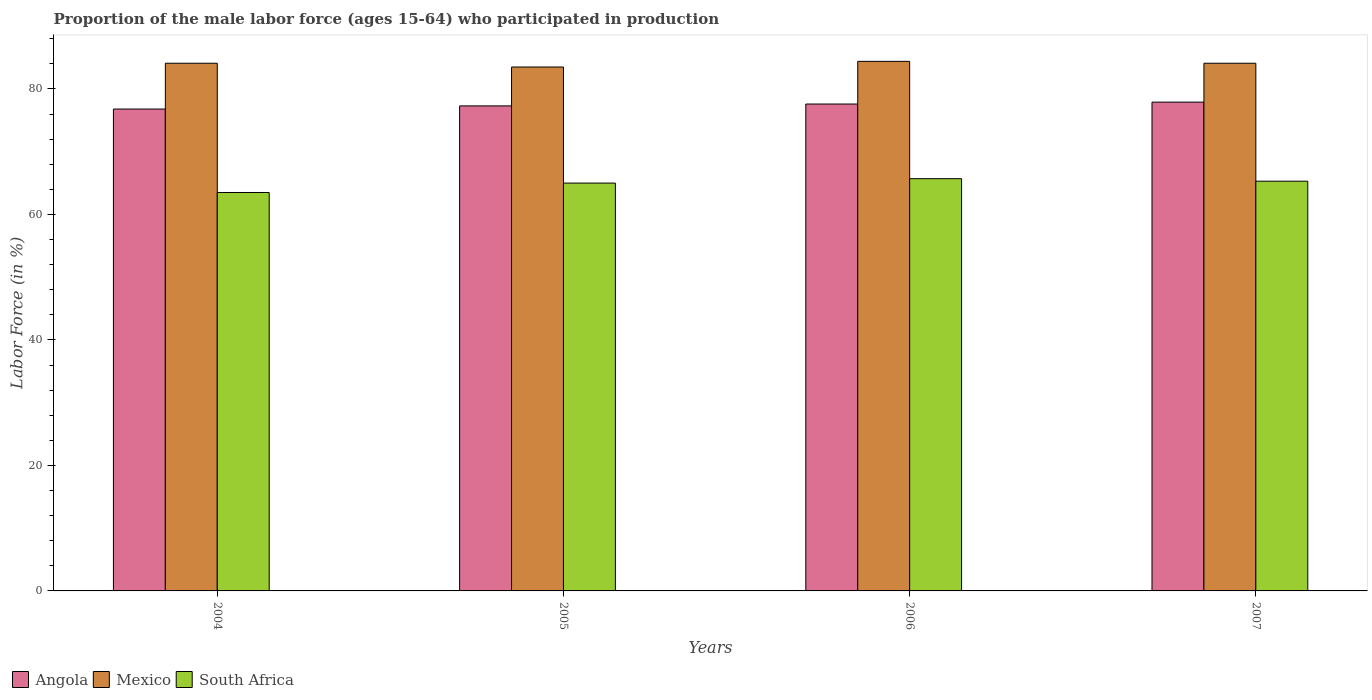How many different coloured bars are there?
Your response must be concise. 3. How many groups of bars are there?
Give a very brief answer. 4. Are the number of bars per tick equal to the number of legend labels?
Provide a short and direct response. Yes. Are the number of bars on each tick of the X-axis equal?
Ensure brevity in your answer.  Yes. How many bars are there on the 3rd tick from the left?
Provide a succinct answer. 3. What is the label of the 4th group of bars from the left?
Your answer should be compact. 2007. Across all years, what is the maximum proportion of the male labor force who participated in production in Angola?
Your answer should be very brief. 77.9. Across all years, what is the minimum proportion of the male labor force who participated in production in Angola?
Give a very brief answer. 76.8. In which year was the proportion of the male labor force who participated in production in South Africa minimum?
Ensure brevity in your answer.  2004. What is the total proportion of the male labor force who participated in production in South Africa in the graph?
Provide a short and direct response. 259.5. What is the difference between the proportion of the male labor force who participated in production in South Africa in 2004 and that in 2007?
Provide a short and direct response. -1.8. What is the difference between the proportion of the male labor force who participated in production in South Africa in 2007 and the proportion of the male labor force who participated in production in Angola in 2005?
Ensure brevity in your answer.  -12. What is the average proportion of the male labor force who participated in production in Angola per year?
Provide a succinct answer. 77.4. In the year 2005, what is the difference between the proportion of the male labor force who participated in production in Mexico and proportion of the male labor force who participated in production in South Africa?
Your answer should be very brief. 18.5. In how many years, is the proportion of the male labor force who participated in production in South Africa greater than 44 %?
Make the answer very short. 4. What is the ratio of the proportion of the male labor force who participated in production in Angola in 2004 to that in 2005?
Provide a short and direct response. 0.99. Is the proportion of the male labor force who participated in production in South Africa in 2006 less than that in 2007?
Provide a short and direct response. No. What is the difference between the highest and the second highest proportion of the male labor force who participated in production in Mexico?
Offer a very short reply. 0.3. What is the difference between the highest and the lowest proportion of the male labor force who participated in production in Mexico?
Keep it short and to the point. 0.9. In how many years, is the proportion of the male labor force who participated in production in Angola greater than the average proportion of the male labor force who participated in production in Angola taken over all years?
Offer a very short reply. 2. Is the sum of the proportion of the male labor force who participated in production in Angola in 2004 and 2007 greater than the maximum proportion of the male labor force who participated in production in South Africa across all years?
Offer a very short reply. Yes. What does the 2nd bar from the left in 2006 represents?
Give a very brief answer. Mexico. What does the 2nd bar from the right in 2005 represents?
Offer a very short reply. Mexico. Are all the bars in the graph horizontal?
Ensure brevity in your answer.  No. How many years are there in the graph?
Your answer should be very brief. 4. Are the values on the major ticks of Y-axis written in scientific E-notation?
Your response must be concise. No. How many legend labels are there?
Give a very brief answer. 3. What is the title of the graph?
Keep it short and to the point. Proportion of the male labor force (ages 15-64) who participated in production. What is the label or title of the Y-axis?
Your response must be concise. Labor Force (in %). What is the Labor Force (in %) of Angola in 2004?
Give a very brief answer. 76.8. What is the Labor Force (in %) in Mexico in 2004?
Your answer should be compact. 84.1. What is the Labor Force (in %) in South Africa in 2004?
Provide a short and direct response. 63.5. What is the Labor Force (in %) of Angola in 2005?
Make the answer very short. 77.3. What is the Labor Force (in %) of Mexico in 2005?
Your response must be concise. 83.5. What is the Labor Force (in %) of South Africa in 2005?
Ensure brevity in your answer.  65. What is the Labor Force (in %) of Angola in 2006?
Provide a short and direct response. 77.6. What is the Labor Force (in %) in Mexico in 2006?
Your response must be concise. 84.4. What is the Labor Force (in %) of South Africa in 2006?
Your answer should be very brief. 65.7. What is the Labor Force (in %) of Angola in 2007?
Give a very brief answer. 77.9. What is the Labor Force (in %) in Mexico in 2007?
Offer a very short reply. 84.1. What is the Labor Force (in %) of South Africa in 2007?
Give a very brief answer. 65.3. Across all years, what is the maximum Labor Force (in %) of Angola?
Your response must be concise. 77.9. Across all years, what is the maximum Labor Force (in %) in Mexico?
Ensure brevity in your answer.  84.4. Across all years, what is the maximum Labor Force (in %) of South Africa?
Your answer should be compact. 65.7. Across all years, what is the minimum Labor Force (in %) of Angola?
Give a very brief answer. 76.8. Across all years, what is the minimum Labor Force (in %) of Mexico?
Offer a terse response. 83.5. Across all years, what is the minimum Labor Force (in %) of South Africa?
Provide a succinct answer. 63.5. What is the total Labor Force (in %) of Angola in the graph?
Offer a very short reply. 309.6. What is the total Labor Force (in %) of Mexico in the graph?
Provide a short and direct response. 336.1. What is the total Labor Force (in %) of South Africa in the graph?
Make the answer very short. 259.5. What is the difference between the Labor Force (in %) in Mexico in 2004 and that in 2005?
Offer a very short reply. 0.6. What is the difference between the Labor Force (in %) in Mexico in 2004 and that in 2006?
Make the answer very short. -0.3. What is the difference between the Labor Force (in %) in Mexico in 2004 and that in 2007?
Ensure brevity in your answer.  0. What is the difference between the Labor Force (in %) in Angola in 2005 and that in 2006?
Provide a short and direct response. -0.3. What is the difference between the Labor Force (in %) of South Africa in 2005 and that in 2006?
Your answer should be compact. -0.7. What is the difference between the Labor Force (in %) of Mexico in 2006 and that in 2007?
Provide a succinct answer. 0.3. What is the difference between the Labor Force (in %) of Angola in 2004 and the Labor Force (in %) of South Africa in 2005?
Offer a very short reply. 11.8. What is the difference between the Labor Force (in %) of Mexico in 2004 and the Labor Force (in %) of South Africa in 2005?
Your answer should be very brief. 19.1. What is the difference between the Labor Force (in %) in Angola in 2004 and the Labor Force (in %) in South Africa in 2006?
Make the answer very short. 11.1. What is the difference between the Labor Force (in %) of Mexico in 2004 and the Labor Force (in %) of South Africa in 2007?
Provide a short and direct response. 18.8. What is the difference between the Labor Force (in %) in Angola in 2005 and the Labor Force (in %) in Mexico in 2006?
Keep it short and to the point. -7.1. What is the difference between the Labor Force (in %) of Mexico in 2005 and the Labor Force (in %) of South Africa in 2006?
Provide a short and direct response. 17.8. What is the difference between the Labor Force (in %) in Mexico in 2005 and the Labor Force (in %) in South Africa in 2007?
Offer a very short reply. 18.2. What is the difference between the Labor Force (in %) of Angola in 2006 and the Labor Force (in %) of Mexico in 2007?
Offer a terse response. -6.5. What is the difference between the Labor Force (in %) of Angola in 2006 and the Labor Force (in %) of South Africa in 2007?
Ensure brevity in your answer.  12.3. What is the difference between the Labor Force (in %) of Mexico in 2006 and the Labor Force (in %) of South Africa in 2007?
Your answer should be compact. 19.1. What is the average Labor Force (in %) in Angola per year?
Your response must be concise. 77.4. What is the average Labor Force (in %) of Mexico per year?
Keep it short and to the point. 84.03. What is the average Labor Force (in %) in South Africa per year?
Provide a short and direct response. 64.88. In the year 2004, what is the difference between the Labor Force (in %) in Angola and Labor Force (in %) in Mexico?
Provide a succinct answer. -7.3. In the year 2004, what is the difference between the Labor Force (in %) of Angola and Labor Force (in %) of South Africa?
Offer a very short reply. 13.3. In the year 2004, what is the difference between the Labor Force (in %) in Mexico and Labor Force (in %) in South Africa?
Give a very brief answer. 20.6. In the year 2006, what is the difference between the Labor Force (in %) in Angola and Labor Force (in %) in Mexico?
Make the answer very short. -6.8. In the year 2007, what is the difference between the Labor Force (in %) of Angola and Labor Force (in %) of Mexico?
Offer a terse response. -6.2. In the year 2007, what is the difference between the Labor Force (in %) of Angola and Labor Force (in %) of South Africa?
Provide a short and direct response. 12.6. In the year 2007, what is the difference between the Labor Force (in %) of Mexico and Labor Force (in %) of South Africa?
Offer a very short reply. 18.8. What is the ratio of the Labor Force (in %) in South Africa in 2004 to that in 2005?
Offer a very short reply. 0.98. What is the ratio of the Labor Force (in %) of Mexico in 2004 to that in 2006?
Provide a short and direct response. 1. What is the ratio of the Labor Force (in %) of South Africa in 2004 to that in 2006?
Ensure brevity in your answer.  0.97. What is the ratio of the Labor Force (in %) of Angola in 2004 to that in 2007?
Your answer should be very brief. 0.99. What is the ratio of the Labor Force (in %) of South Africa in 2004 to that in 2007?
Offer a very short reply. 0.97. What is the ratio of the Labor Force (in %) of Mexico in 2005 to that in 2006?
Your answer should be very brief. 0.99. What is the ratio of the Labor Force (in %) in South Africa in 2005 to that in 2006?
Your response must be concise. 0.99. What is the ratio of the Labor Force (in %) in Angola in 2005 to that in 2007?
Offer a very short reply. 0.99. What is the ratio of the Labor Force (in %) of Mexico in 2005 to that in 2007?
Provide a short and direct response. 0.99. What is the ratio of the Labor Force (in %) in Angola in 2006 to that in 2007?
Keep it short and to the point. 1. What is the ratio of the Labor Force (in %) of Mexico in 2006 to that in 2007?
Your response must be concise. 1. What is the difference between the highest and the second highest Labor Force (in %) of Mexico?
Offer a very short reply. 0.3. What is the difference between the highest and the second highest Labor Force (in %) of South Africa?
Provide a short and direct response. 0.4. What is the difference between the highest and the lowest Labor Force (in %) of South Africa?
Give a very brief answer. 2.2. 